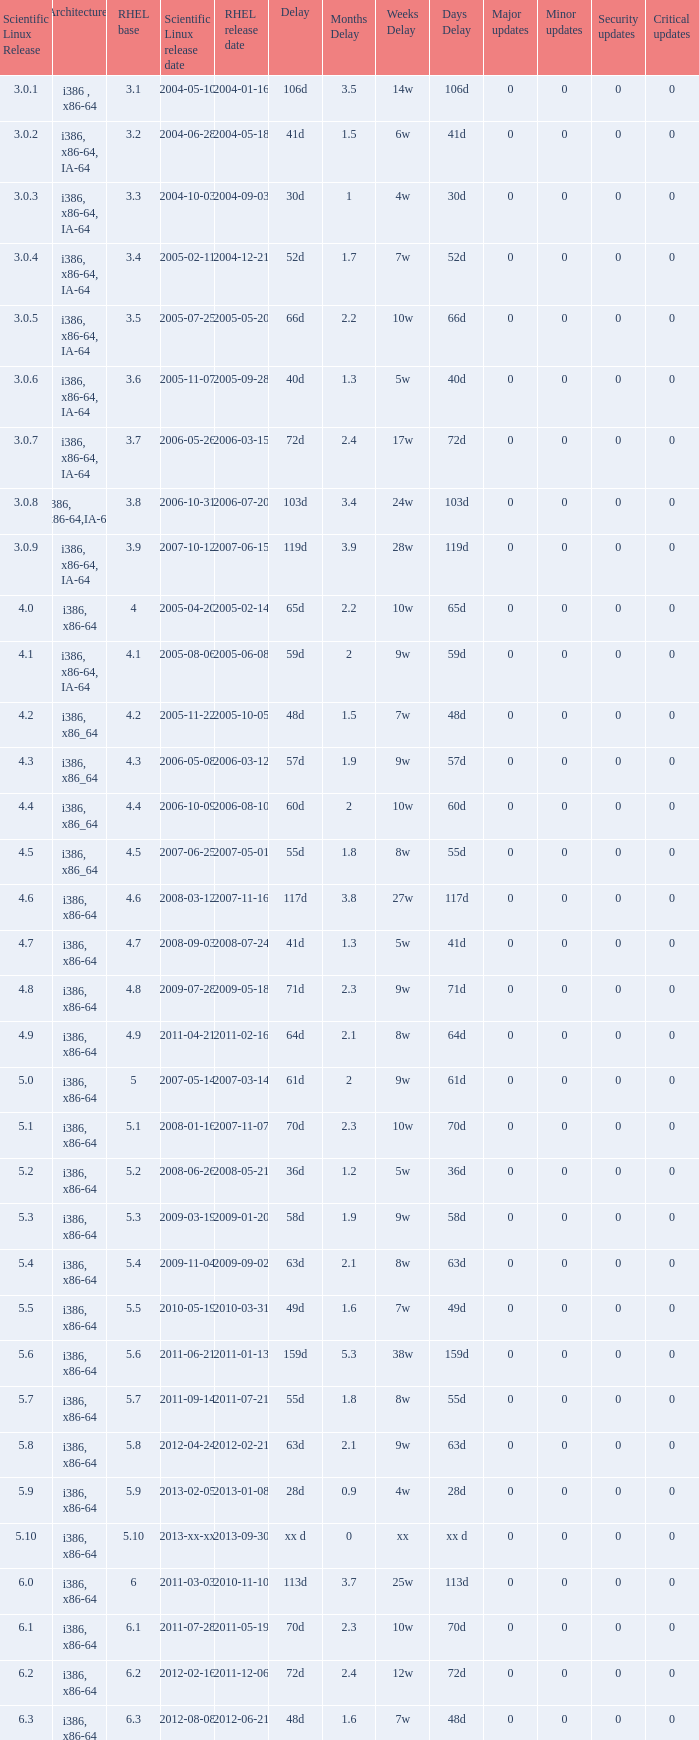Name the scientific linux release when delay is 28d 5.9. 